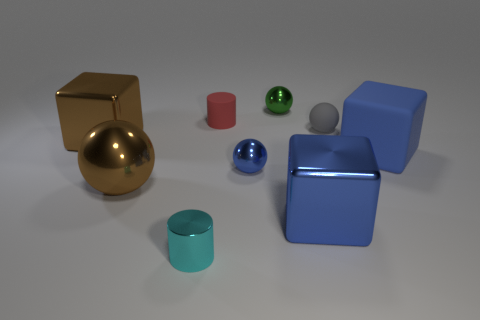Add 1 tiny red matte balls. How many objects exist? 10 Subtract all balls. How many objects are left? 5 Subtract 1 red cylinders. How many objects are left? 8 Subtract all large rubber objects. Subtract all tiny balls. How many objects are left? 5 Add 2 small gray rubber objects. How many small gray rubber objects are left? 3 Add 4 brown things. How many brown things exist? 6 